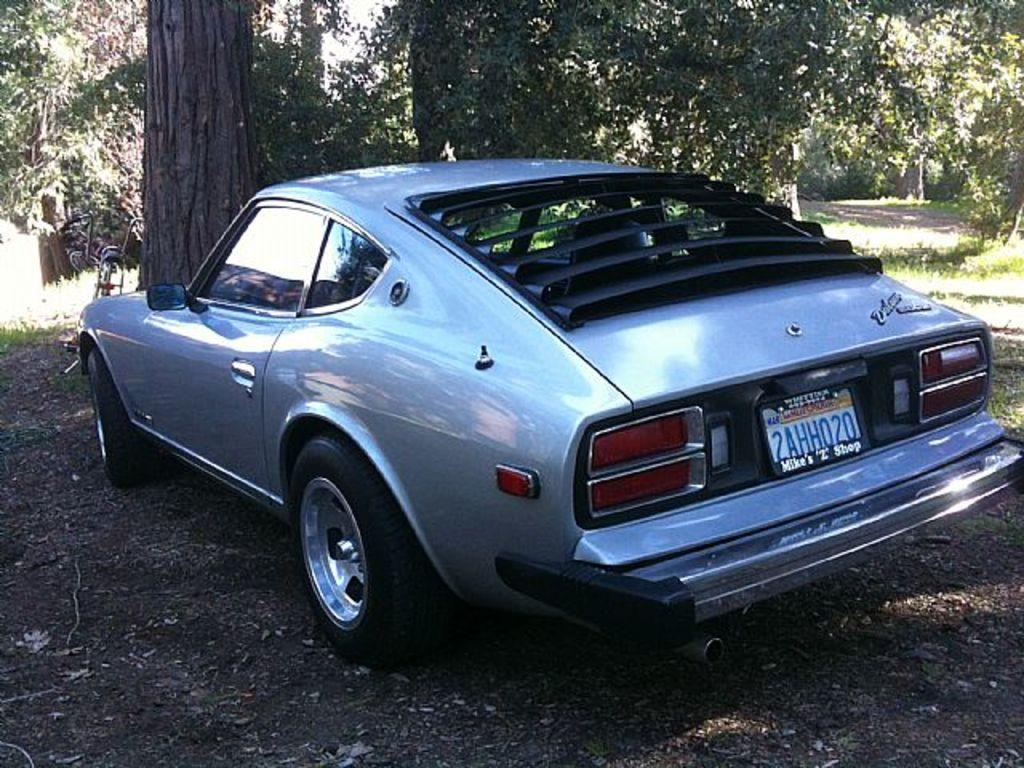What type of vehicle is in the image? There is a car in the image. Can you describe any specific features of the car? The car has a number plate. What can be seen in the background of the image? There are trees visible in the background. What other mode of transportation is in the image? There is a cycle in the image. What type of ground surface is present in the image? Grass is present on the ground in the image. What year is the river mentioned in the image? There is no river present in the image, so it is not possible to determine the year it is mentioned. 